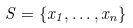Convert formula to latex. <formula><loc_0><loc_0><loc_500><loc_500>S = \{ x _ { 1 } , \dots , x _ { n } \}</formula> 